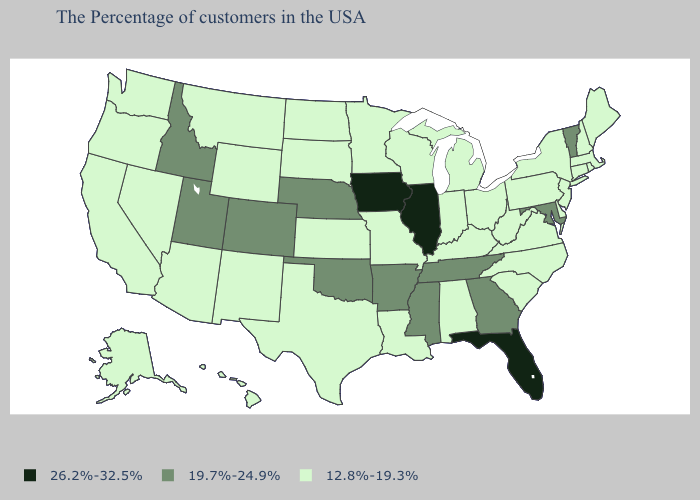What is the value of North Carolina?
Be succinct. 12.8%-19.3%. Does Oregon have the highest value in the West?
Short answer required. No. What is the value of South Carolina?
Concise answer only. 12.8%-19.3%. Does Florida have the highest value in the USA?
Quick response, please. Yes. Which states have the lowest value in the USA?
Answer briefly. Maine, Massachusetts, Rhode Island, New Hampshire, Connecticut, New York, New Jersey, Delaware, Pennsylvania, Virginia, North Carolina, South Carolina, West Virginia, Ohio, Michigan, Kentucky, Indiana, Alabama, Wisconsin, Louisiana, Missouri, Minnesota, Kansas, Texas, South Dakota, North Dakota, Wyoming, New Mexico, Montana, Arizona, Nevada, California, Washington, Oregon, Alaska, Hawaii. Among the states that border Nebraska , does Colorado have the highest value?
Keep it brief. No. What is the lowest value in the USA?
Quick response, please. 12.8%-19.3%. Name the states that have a value in the range 26.2%-32.5%?
Give a very brief answer. Florida, Illinois, Iowa. What is the value of Arizona?
Keep it brief. 12.8%-19.3%. Which states have the highest value in the USA?
Short answer required. Florida, Illinois, Iowa. Does California have the highest value in the West?
Quick response, please. No. Name the states that have a value in the range 12.8%-19.3%?
Write a very short answer. Maine, Massachusetts, Rhode Island, New Hampshire, Connecticut, New York, New Jersey, Delaware, Pennsylvania, Virginia, North Carolina, South Carolina, West Virginia, Ohio, Michigan, Kentucky, Indiana, Alabama, Wisconsin, Louisiana, Missouri, Minnesota, Kansas, Texas, South Dakota, North Dakota, Wyoming, New Mexico, Montana, Arizona, Nevada, California, Washington, Oregon, Alaska, Hawaii. Name the states that have a value in the range 12.8%-19.3%?
Be succinct. Maine, Massachusetts, Rhode Island, New Hampshire, Connecticut, New York, New Jersey, Delaware, Pennsylvania, Virginia, North Carolina, South Carolina, West Virginia, Ohio, Michigan, Kentucky, Indiana, Alabama, Wisconsin, Louisiana, Missouri, Minnesota, Kansas, Texas, South Dakota, North Dakota, Wyoming, New Mexico, Montana, Arizona, Nevada, California, Washington, Oregon, Alaska, Hawaii. What is the value of Alabama?
Short answer required. 12.8%-19.3%. What is the value of Arizona?
Concise answer only. 12.8%-19.3%. 